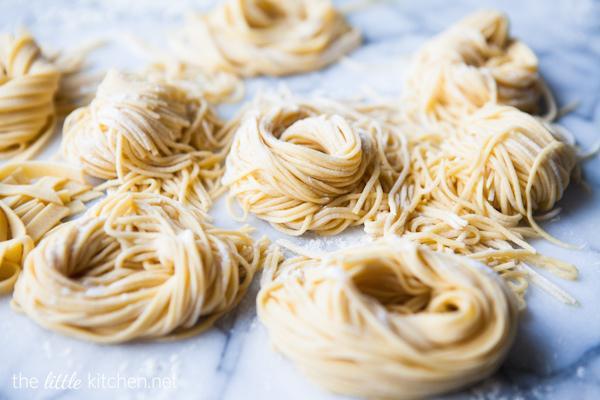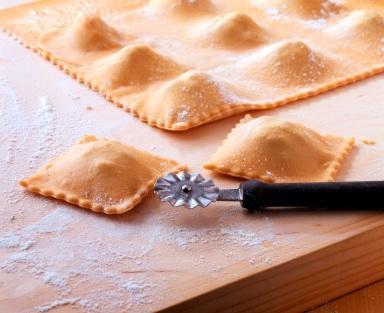The first image is the image on the left, the second image is the image on the right. Considering the images on both sides, is "A cooking instrument is seen on the table in one of the images." valid? Answer yes or no. Yes. The first image is the image on the left, the second image is the image on the right. For the images displayed, is the sentence "One image includes a floured board and squarish pastries with mounded middles and scalloped edges, and the other image features noodles in a pile." factually correct? Answer yes or no. Yes. 